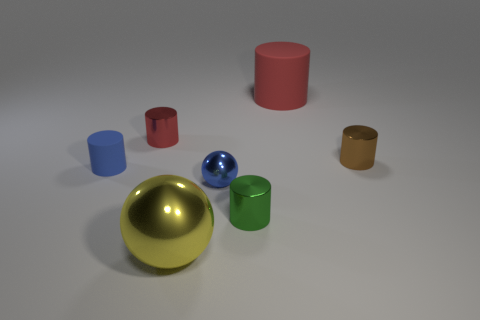Subtract 2 cylinders. How many cylinders are left? 3 Subtract all brown cylinders. How many cylinders are left? 4 Subtract all gray cylinders. Subtract all cyan blocks. How many cylinders are left? 5 Add 2 cylinders. How many objects exist? 9 Subtract all cylinders. How many objects are left? 2 Subtract all red metallic objects. Subtract all red shiny objects. How many objects are left? 5 Add 6 large yellow shiny balls. How many large yellow shiny balls are left? 7 Add 3 yellow objects. How many yellow objects exist? 4 Subtract 0 purple balls. How many objects are left? 7 